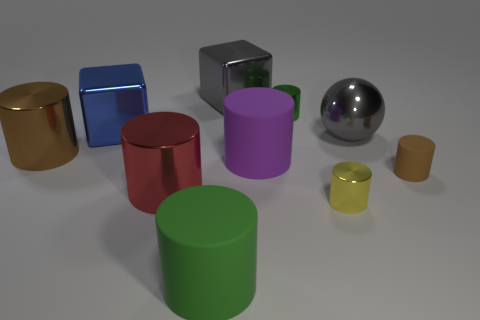Is there any other thing that is the same size as the gray shiny ball?
Provide a succinct answer. Yes. Do the brown shiny object and the big red object have the same shape?
Ensure brevity in your answer.  Yes. What number of other large matte objects have the same shape as the big green rubber thing?
Your response must be concise. 1. There is a small yellow shiny thing; how many big gray objects are to the left of it?
Offer a terse response. 1. Does the small thing that is behind the sphere have the same color as the large sphere?
Keep it short and to the point. No. How many purple rubber objects have the same size as the shiny sphere?
Offer a very short reply. 1. What shape is the blue thing that is the same material as the large gray ball?
Give a very brief answer. Cube. Are there any metallic objects of the same color as the big metal sphere?
Make the answer very short. Yes. What is the material of the big blue object?
Make the answer very short. Metal. How many objects are small yellow metal cylinders or tiny yellow spheres?
Keep it short and to the point. 1. 